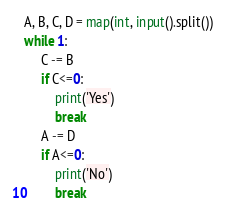<code> <loc_0><loc_0><loc_500><loc_500><_Python_>A, B, C, D = map(int, input().split())
while 1:
     C -= B
     if C<=0:
         print('Yes')
         break
     A -= D
     if A<=0:
         print('No')
         break</code> 